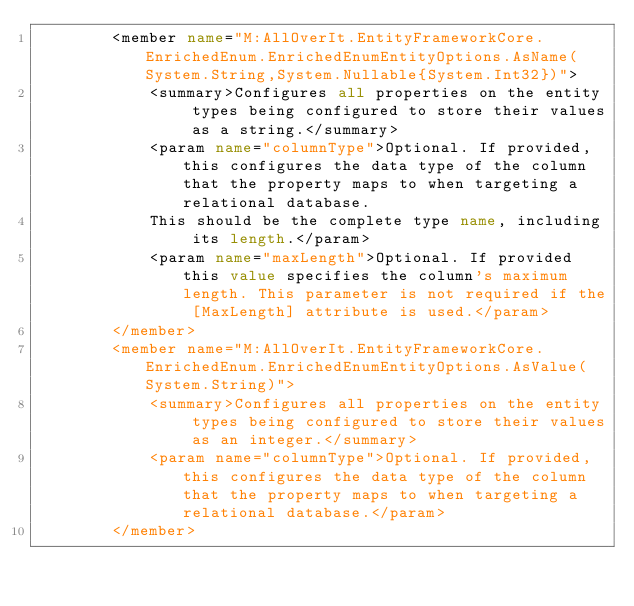<code> <loc_0><loc_0><loc_500><loc_500><_XML_>        <member name="M:AllOverIt.EntityFrameworkCore.EnrichedEnum.EnrichedEnumEntityOptions.AsName(System.String,System.Nullable{System.Int32})">
            <summary>Configures all properties on the entity types being configured to store their values as a string.</summary>
            <param name="columnType">Optional. If provided, this configures the data type of the column that the property maps to when targeting a relational database.
            This should be the complete type name, including its length.</param>
            <param name="maxLength">Optional. If provided this value specifies the column's maximum length. This parameter is not required if the [MaxLength] attribute is used.</param>
        </member>
        <member name="M:AllOverIt.EntityFrameworkCore.EnrichedEnum.EnrichedEnumEntityOptions.AsValue(System.String)">
            <summary>Configures all properties on the entity types being configured to store their values as an integer.</summary>
            <param name="columnType">Optional. If provided, this configures the data type of the column that the property maps to when targeting a relational database.</param>
        </member></code> 